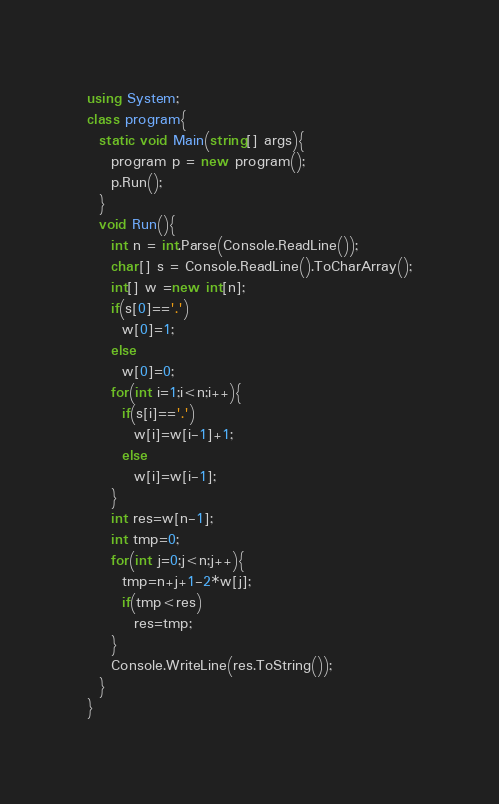<code> <loc_0><loc_0><loc_500><loc_500><_C#_>using System;
class program{
  static void Main(string[] args){
    program p = new program();
    p.Run();
  }
  void Run(){
	int n = int.Parse(Console.ReadLine());
    char[] s = Console.ReadLine().ToCharArray();
    int[] w =new int[n];
    if(s[0]=='.')
      w[0]=1;
    else
      w[0]=0;
    for(int i=1;i<n;i++){
      if(s[i]=='.')
        w[i]=w[i-1]+1;
      else
        w[i]=w[i-1];
    }
    int res=w[n-1];
    int tmp=0;
    for(int j=0;j<n;j++){
      tmp=n+j+1-2*w[j];
      if(tmp<res)
        res=tmp;
    }
    Console.WriteLine(res.ToString());
  }
}
</code> 